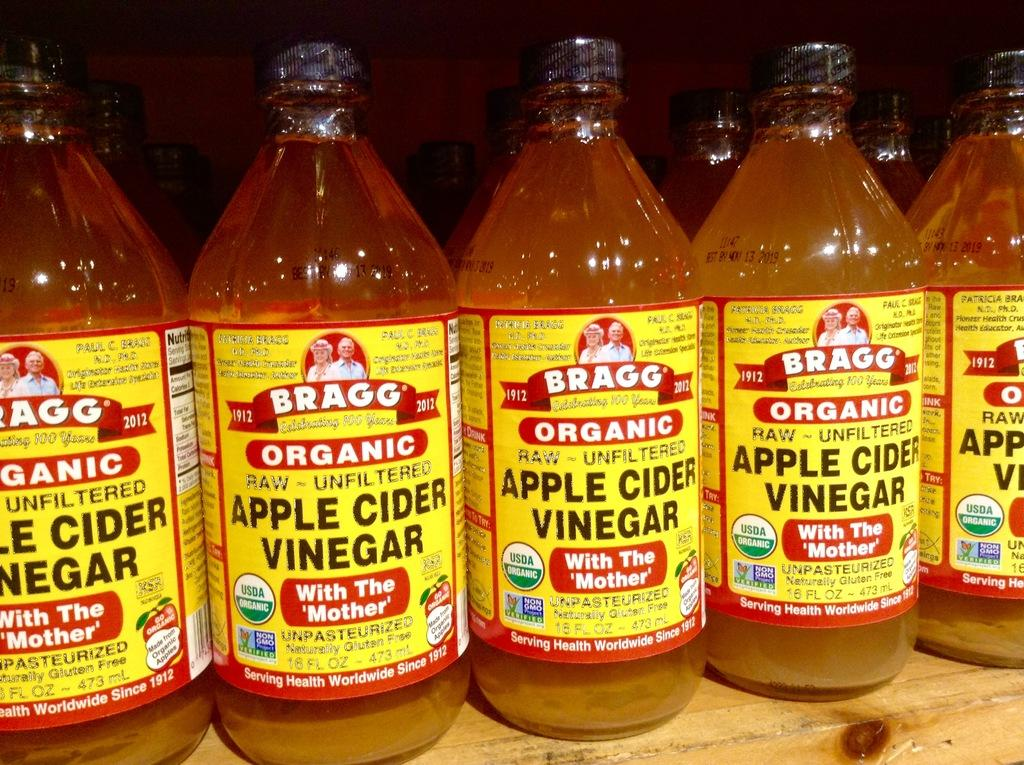What objects are present in the image? There are bottles in the image. What are the bottles filled with? The bottles are filled with liquids. Are there any additional features on the bottles? Yes, there are stickers on the bottles. What type of bears can be seen interacting with the paint in the image? There are no bears or paint present in the image; it only features bottles with stickers. 